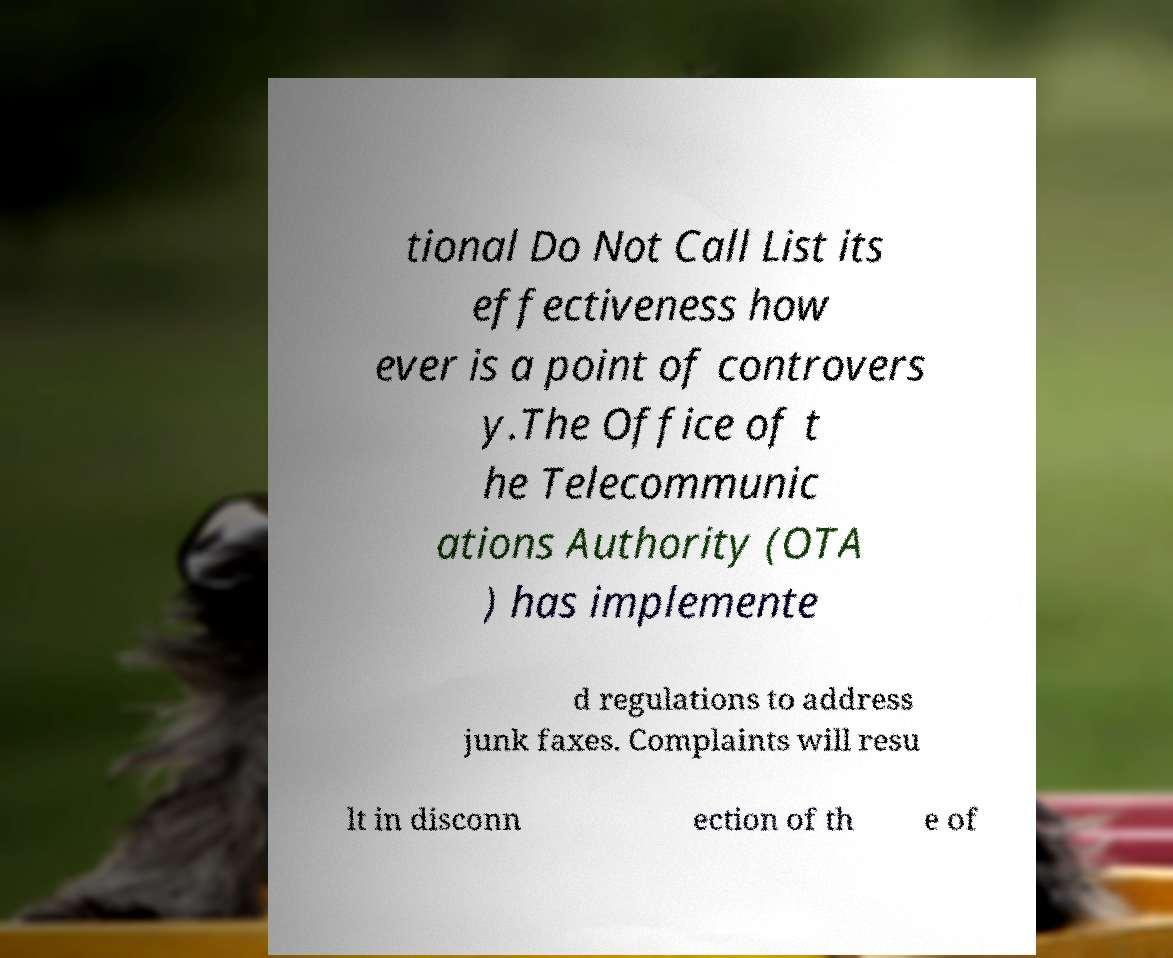For documentation purposes, I need the text within this image transcribed. Could you provide that? tional Do Not Call List its effectiveness how ever is a point of controvers y.The Office of t he Telecommunic ations Authority (OTA ) has implemente d regulations to address junk faxes. Complaints will resu lt in disconn ection of th e of 